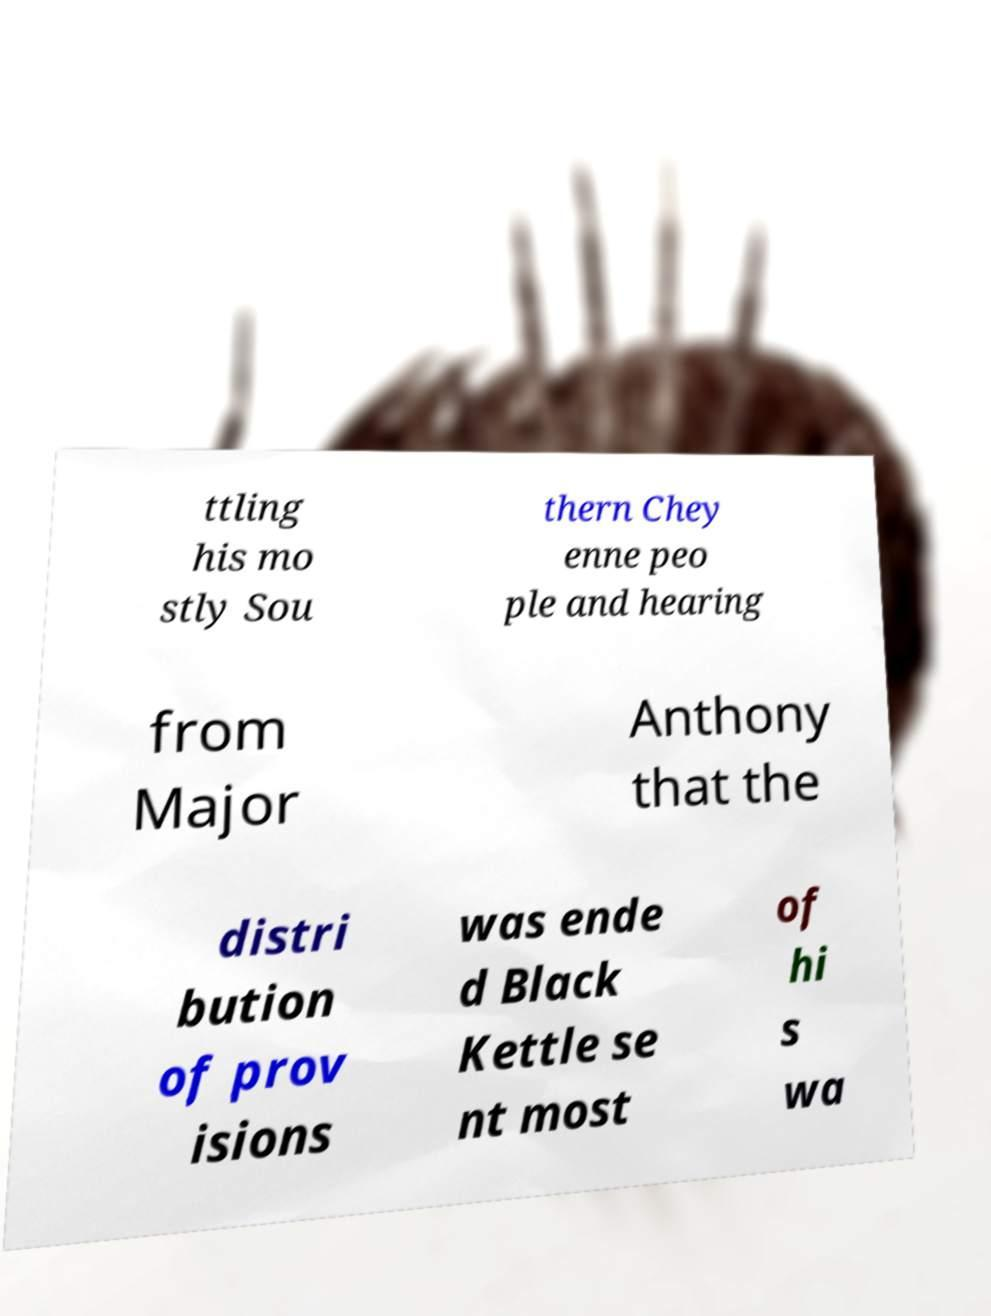Please identify and transcribe the text found in this image. ttling his mo stly Sou thern Chey enne peo ple and hearing from Major Anthony that the distri bution of prov isions was ende d Black Kettle se nt most of hi s wa 